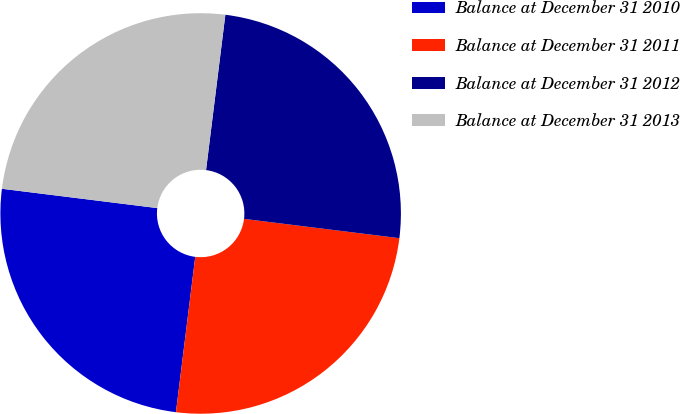Convert chart to OTSL. <chart><loc_0><loc_0><loc_500><loc_500><pie_chart><fcel>Balance at December 31 2010<fcel>Balance at December 31 2011<fcel>Balance at December 31 2012<fcel>Balance at December 31 2013<nl><fcel>25.0%<fcel>25.0%<fcel>25.0%<fcel>25.0%<nl></chart> 